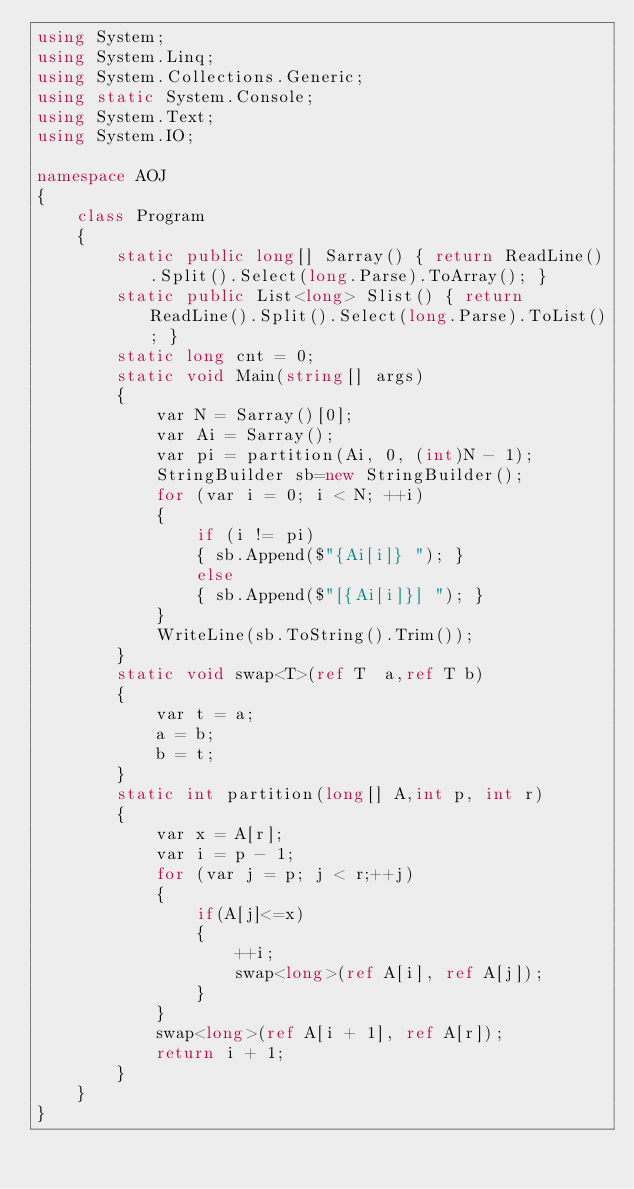<code> <loc_0><loc_0><loc_500><loc_500><_C#_>using System;
using System.Linq;
using System.Collections.Generic;
using static System.Console;
using System.Text;
using System.IO;

namespace AOJ
{
    class Program
    {
        static public long[] Sarray() { return ReadLine().Split().Select(long.Parse).ToArray(); }
        static public List<long> Slist() { return ReadLine().Split().Select(long.Parse).ToList(); }
        static long cnt = 0;
        static void Main(string[] args)
        {
            var N = Sarray()[0];
            var Ai = Sarray();
            var pi = partition(Ai, 0, (int)N - 1);
            StringBuilder sb=new StringBuilder();
            for (var i = 0; i < N; ++i)
            {
                if (i != pi)
                { sb.Append($"{Ai[i]} "); }
                else
                { sb.Append($"[{Ai[i]}] "); }
            }
            WriteLine(sb.ToString().Trim());
        }
        static void swap<T>(ref T  a,ref T b)
        {
            var t = a;
            a = b;
            b = t;
        }
        static int partition(long[] A,int p, int r)
        {
            var x = A[r];
            var i = p - 1;
            for (var j = p; j < r;++j)
            {
                if(A[j]<=x)
                {
                    ++i;
                    swap<long>(ref A[i], ref A[j]);
                }
            }
            swap<long>(ref A[i + 1], ref A[r]);
            return i + 1;
        }
    }
}

</code> 